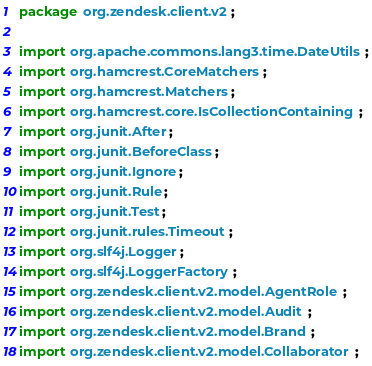Convert code to text. <code><loc_0><loc_0><loc_500><loc_500><_Java_>package org.zendesk.client.v2;

import org.apache.commons.lang3.time.DateUtils;
import org.hamcrest.CoreMatchers;
import org.hamcrest.Matchers;
import org.hamcrest.core.IsCollectionContaining;
import org.junit.After;
import org.junit.BeforeClass;
import org.junit.Ignore;
import org.junit.Rule;
import org.junit.Test;
import org.junit.rules.Timeout;
import org.slf4j.Logger;
import org.slf4j.LoggerFactory;
import org.zendesk.client.v2.model.AgentRole;
import org.zendesk.client.v2.model.Audit;
import org.zendesk.client.v2.model.Brand;
import org.zendesk.client.v2.model.Collaborator;</code> 